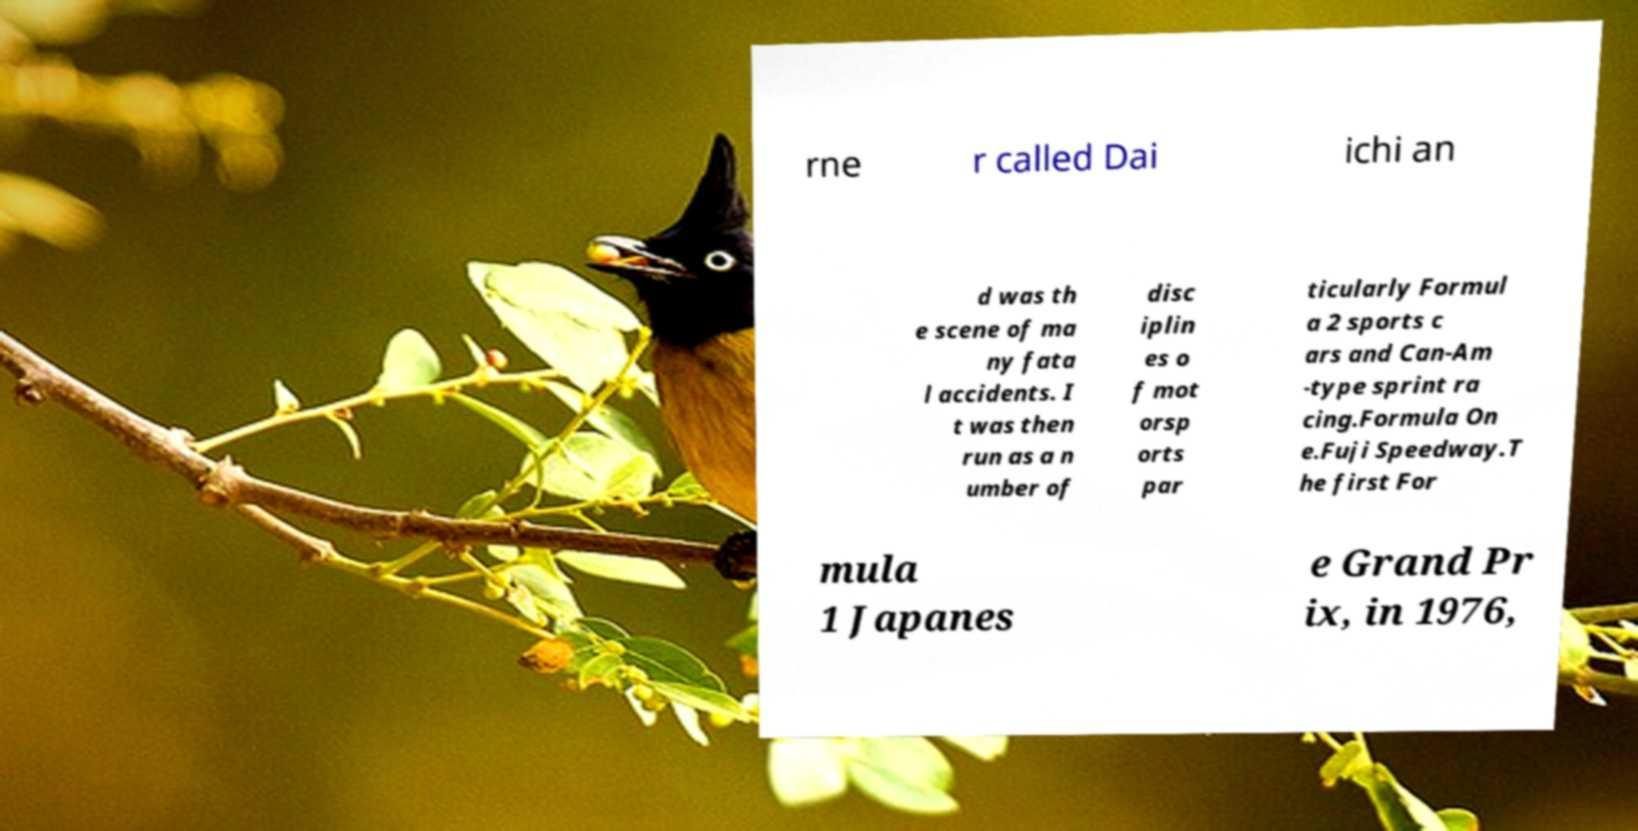For documentation purposes, I need the text within this image transcribed. Could you provide that? rne r called Dai ichi an d was th e scene of ma ny fata l accidents. I t was then run as a n umber of disc iplin es o f mot orsp orts par ticularly Formul a 2 sports c ars and Can-Am -type sprint ra cing.Formula On e.Fuji Speedway.T he first For mula 1 Japanes e Grand Pr ix, in 1976, 